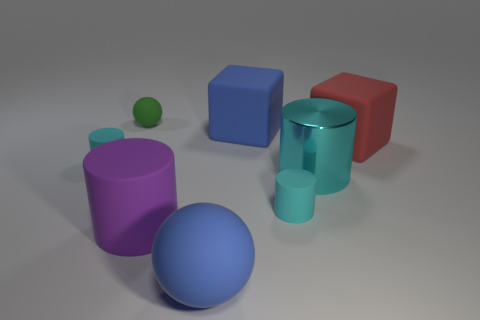Subtract all cyan cylinders. How many cylinders are left? 1 Add 2 small cyan rubber objects. How many objects exist? 10 Subtract all red blocks. How many blocks are left? 1 Subtract all cyan blocks. How many cyan cylinders are left? 3 Subtract all cubes. How many objects are left? 6 Subtract all big gray rubber things. Subtract all big shiny cylinders. How many objects are left? 7 Add 2 big things. How many big things are left? 7 Add 4 small cyan rubber objects. How many small cyan rubber objects exist? 6 Subtract 0 red cylinders. How many objects are left? 8 Subtract 2 spheres. How many spheres are left? 0 